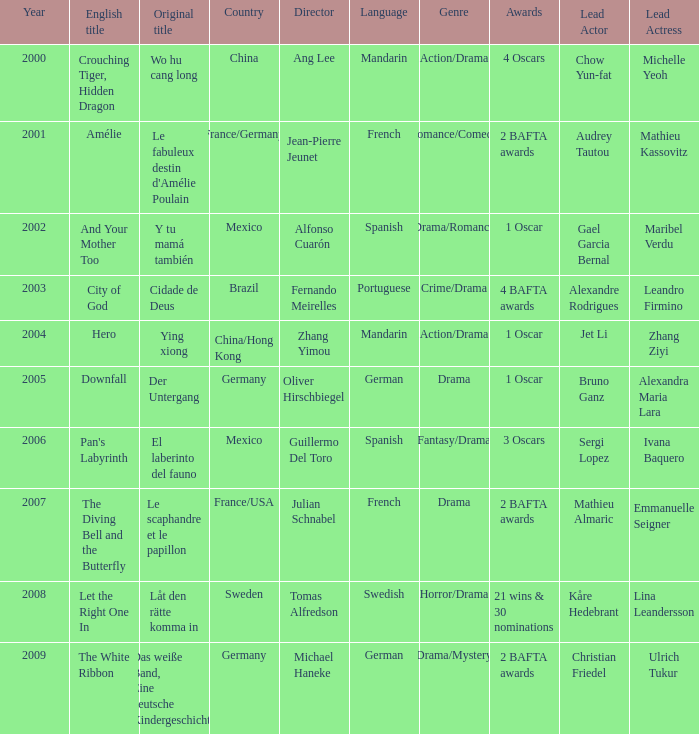Name the title of jean-pierre jeunet Amélie. 